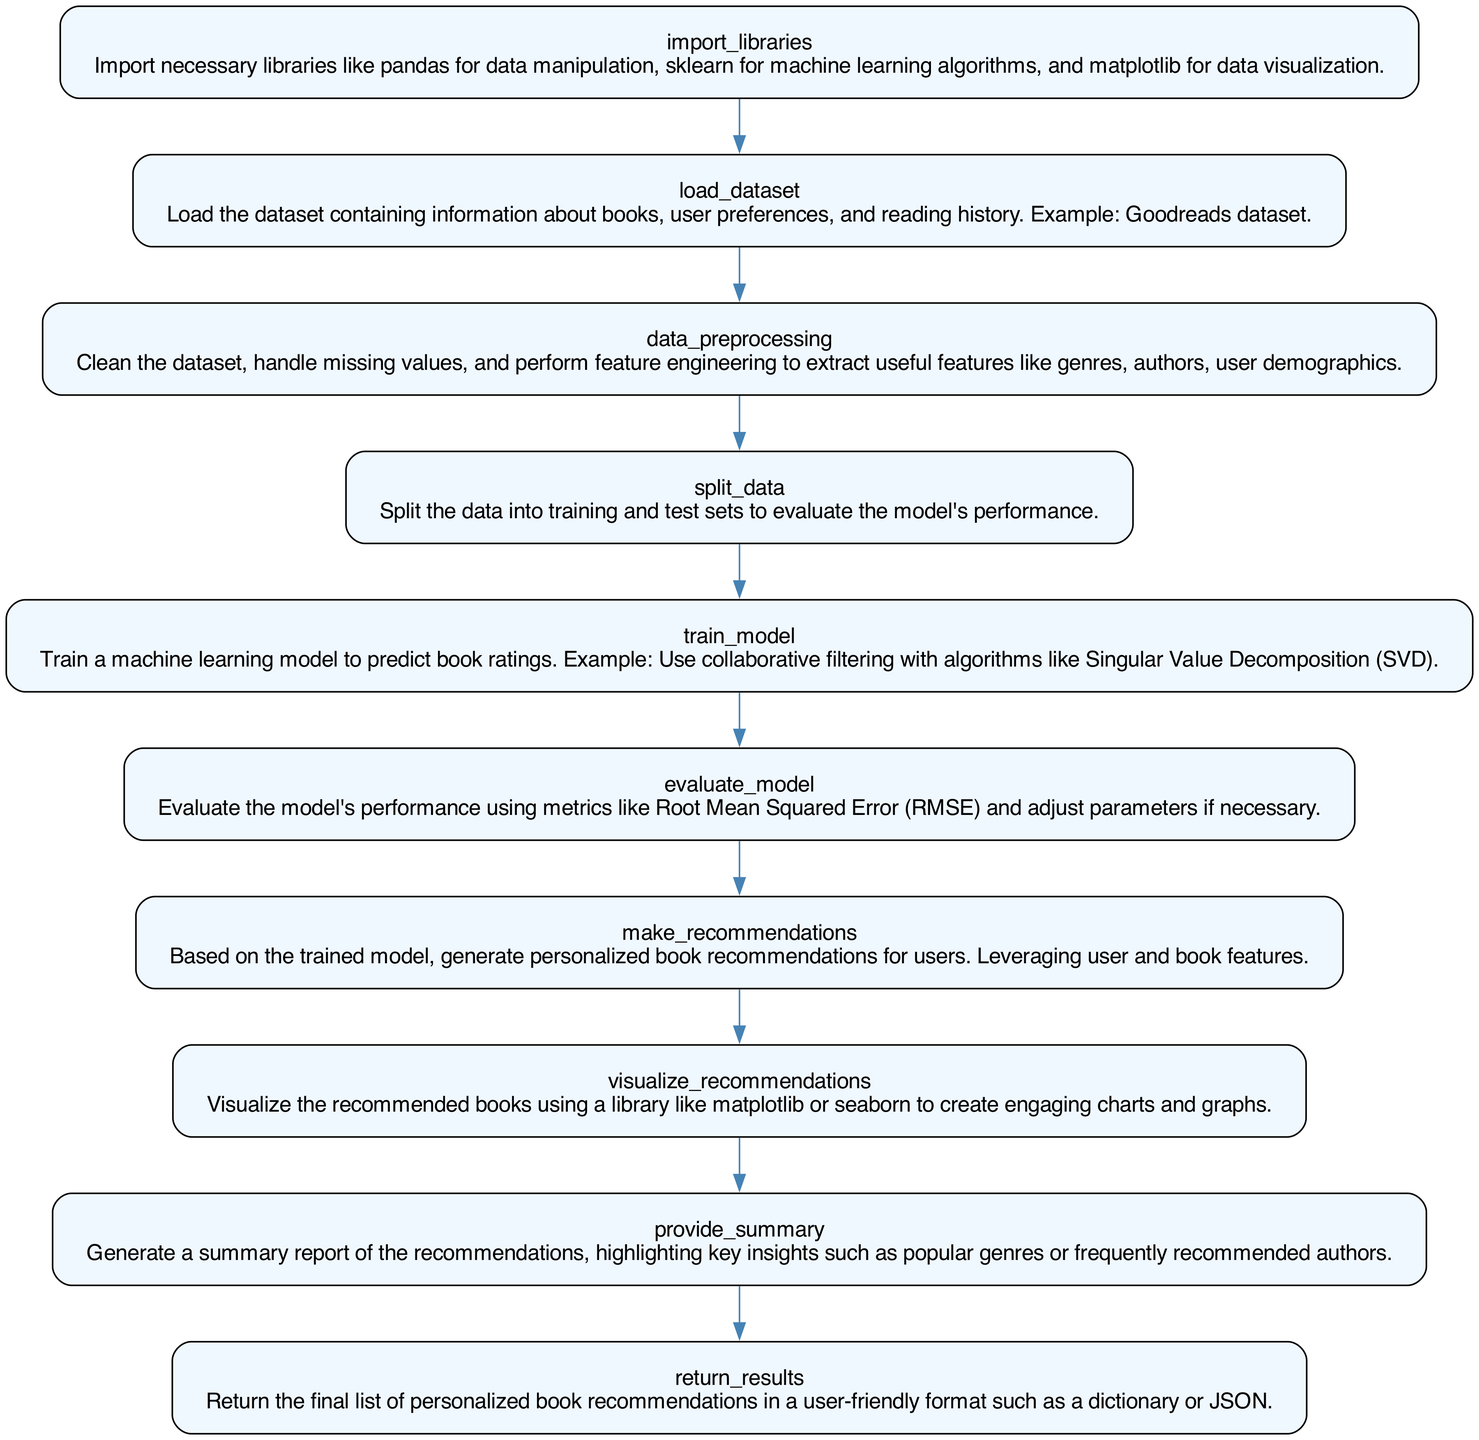What is the first step in the process? The diagram shows that the first step is "import libraries," which involves bringing in necessary libraries for data analysis and machine learning.
Answer: import libraries How many nodes are present in the diagram? By counting the nodes representing each step in the flowchart, there are 10 distinct elements.
Answer: 10 What is the last node in the flowchart? The last step in the process is "return results," which indicates that this is where personalized recommendations are finalized and outputted.
Answer: return results Which node involves model performance evaluation? The "evaluate model" node is specifically dedicated to assessing the performance of the machine learning model with metrics like RMSE.
Answer: evaluate model What is created after the "make recommendations" step? Following the "make recommendations" step, the next action is to "visualize recommendations," meaning the recommended books will be plotted or represented graphically.
Answer: visualize recommendations Which two nodes are directly related to the training of the model? The "split data" node is followed by the "train model" node, indicating that data preparation leads to model training.
Answer: split data, train model What kind of insights are generated at the end of the flow? The "provide summary" node generates key insights such as popular genres or frequently recommended authors after recommendations have been made.
Answer: provide summary What does the "data preprocessing" node handle? This node is focused on cleaning the dataset, managing missing values, and creating useful features for further processing.
Answer: cleaning the dataset Which node utilizes collaborative filtering? The "train model" step specifically mentions using collaborative filtering algorithms like Singular Value Decomposition (SVD) for training.
Answer: train model How does the flowchart visualize the recommendation results? After the recommendations are made, the flowchart indicates that results are visualized through the "visualize recommendations" step, which uses libraries for engaging graphics.
Answer: visualize recommendations 